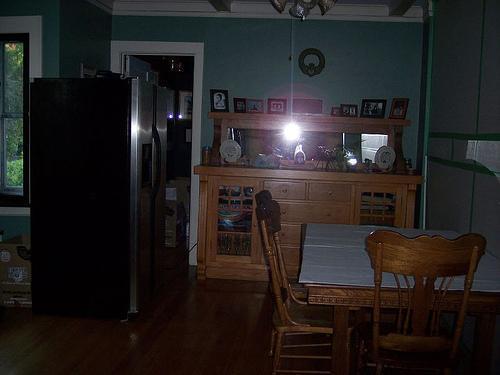What is the large silver object to the left used to store?
Select the accurate answer and provide explanation: 'Answer: answer
Rationale: rationale.'
Options: Animals, clothing, toys, food. Answer: food.
Rationale: It is a fridge. 